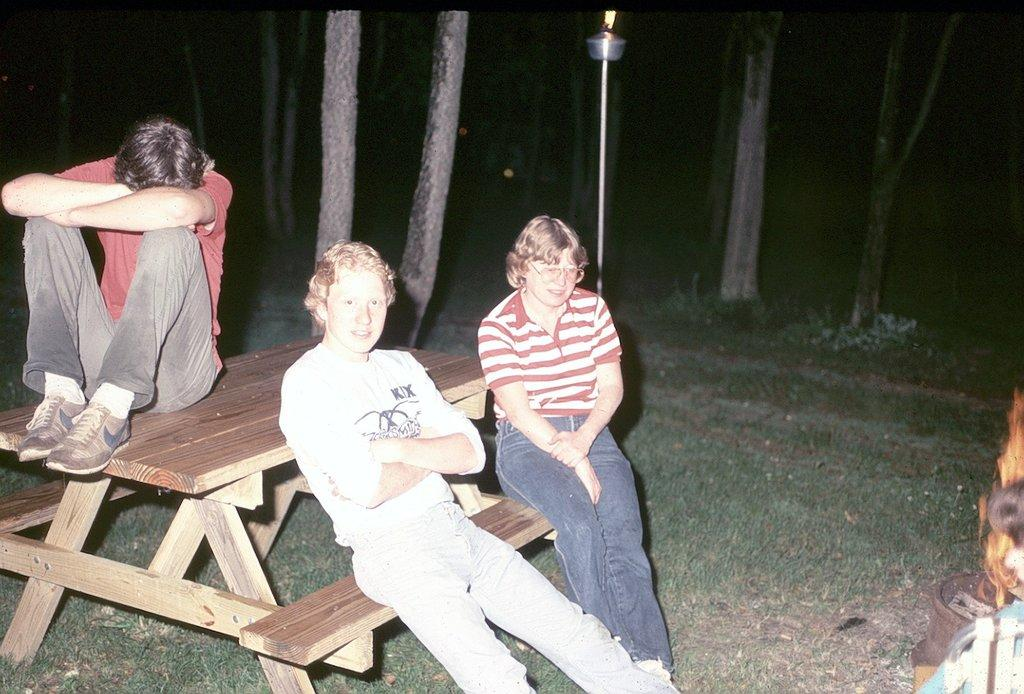How many people are in the image? There are three persons in the image. What are the persons doing in the image? All three persons are sitting. What can be seen in the background of the image? There are trees, grass, and a fire in the background of the image. What time of day is it in the image, according to the hour hand on the grandfather's skate? There is no grandfather or skate present in the image, and therefore no hour hand to determine the time of day. 